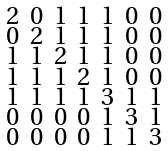Convert formula to latex. <formula><loc_0><loc_0><loc_500><loc_500>\begin{smallmatrix} 2 & 0 & 1 & 1 & 1 & 0 & 0 \\ 0 & 2 & 1 & 1 & 1 & 0 & 0 \\ 1 & 1 & 2 & 1 & 1 & 0 & 0 \\ 1 & 1 & 1 & 2 & 1 & 0 & 0 \\ 1 & 1 & 1 & 1 & 3 & 1 & 1 \\ 0 & 0 & 0 & 0 & 1 & 3 & 1 \\ 0 & 0 & 0 & 0 & 1 & 1 & 3 \end{smallmatrix}</formula> 